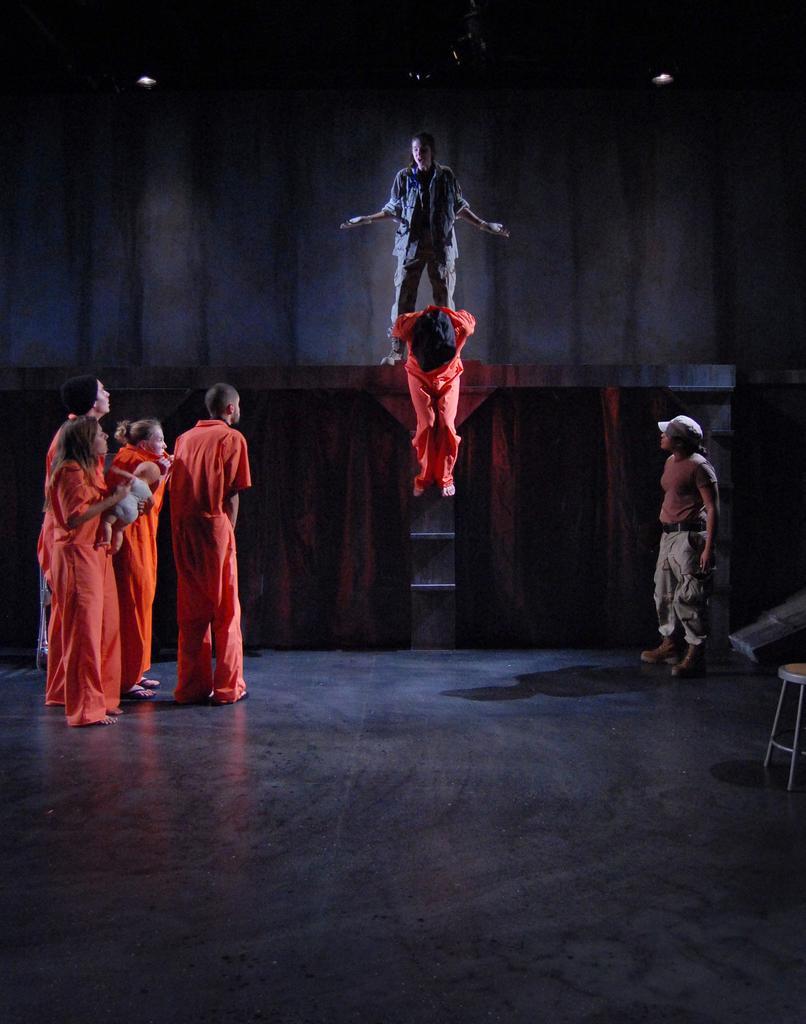Describe this image in one or two sentences. Here in this picture we can see a group of people standing on the floor over there and in the middle we can see a person hanging and behind him we can see another person standing on the stage over there and this looks like an act in a play and on the roof we can see lights present and on the right side we can see a stool also present over there. 